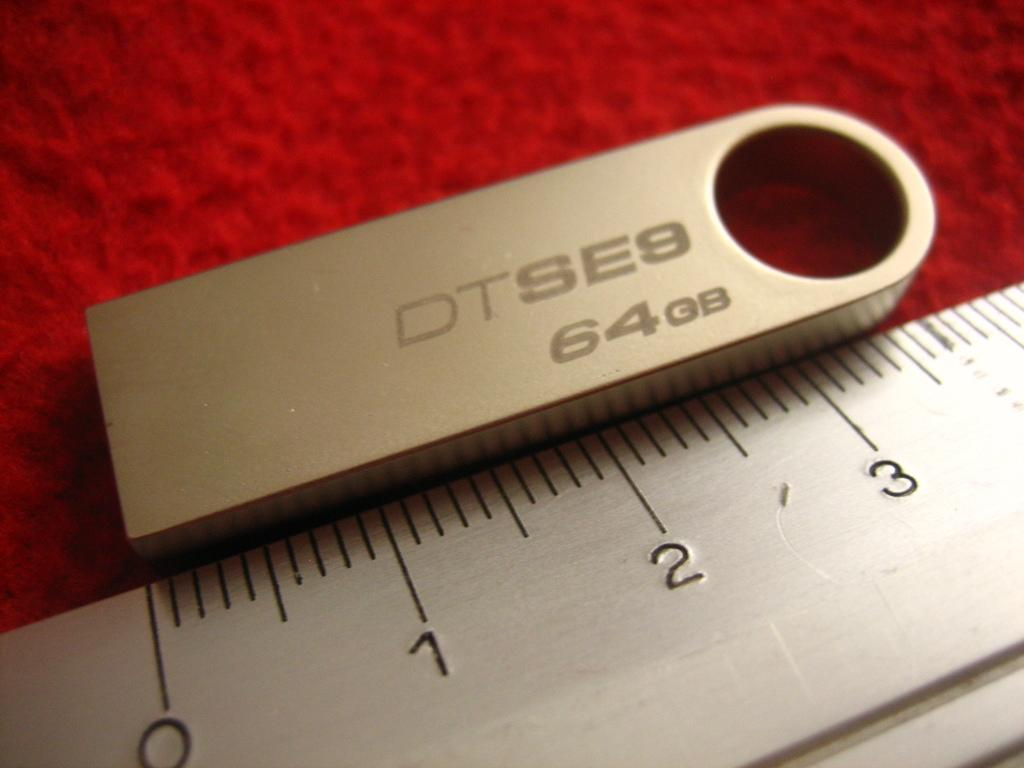<image>
Share a concise interpretation of the image provided. A ruler laying on a red carpet measures a 64 gigabit thumb drive. 